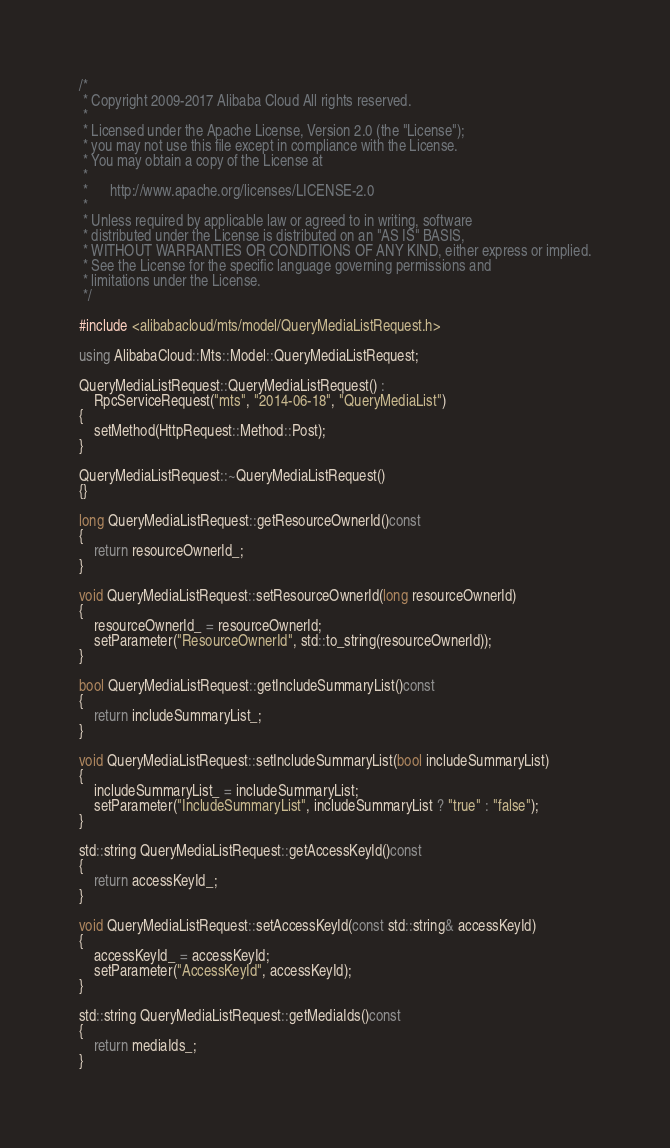<code> <loc_0><loc_0><loc_500><loc_500><_C++_>/*
 * Copyright 2009-2017 Alibaba Cloud All rights reserved.
 * 
 * Licensed under the Apache License, Version 2.0 (the "License");
 * you may not use this file except in compliance with the License.
 * You may obtain a copy of the License at
 * 
 *      http://www.apache.org/licenses/LICENSE-2.0
 * 
 * Unless required by applicable law or agreed to in writing, software
 * distributed under the License is distributed on an "AS IS" BASIS,
 * WITHOUT WARRANTIES OR CONDITIONS OF ANY KIND, either express or implied.
 * See the License for the specific language governing permissions and
 * limitations under the License.
 */

#include <alibabacloud/mts/model/QueryMediaListRequest.h>

using AlibabaCloud::Mts::Model::QueryMediaListRequest;

QueryMediaListRequest::QueryMediaListRequest() :
	RpcServiceRequest("mts", "2014-06-18", "QueryMediaList")
{
	setMethod(HttpRequest::Method::Post);
}

QueryMediaListRequest::~QueryMediaListRequest()
{}

long QueryMediaListRequest::getResourceOwnerId()const
{
	return resourceOwnerId_;
}

void QueryMediaListRequest::setResourceOwnerId(long resourceOwnerId)
{
	resourceOwnerId_ = resourceOwnerId;
	setParameter("ResourceOwnerId", std::to_string(resourceOwnerId));
}

bool QueryMediaListRequest::getIncludeSummaryList()const
{
	return includeSummaryList_;
}

void QueryMediaListRequest::setIncludeSummaryList(bool includeSummaryList)
{
	includeSummaryList_ = includeSummaryList;
	setParameter("IncludeSummaryList", includeSummaryList ? "true" : "false");
}

std::string QueryMediaListRequest::getAccessKeyId()const
{
	return accessKeyId_;
}

void QueryMediaListRequest::setAccessKeyId(const std::string& accessKeyId)
{
	accessKeyId_ = accessKeyId;
	setParameter("AccessKeyId", accessKeyId);
}

std::string QueryMediaListRequest::getMediaIds()const
{
	return mediaIds_;
}
</code> 